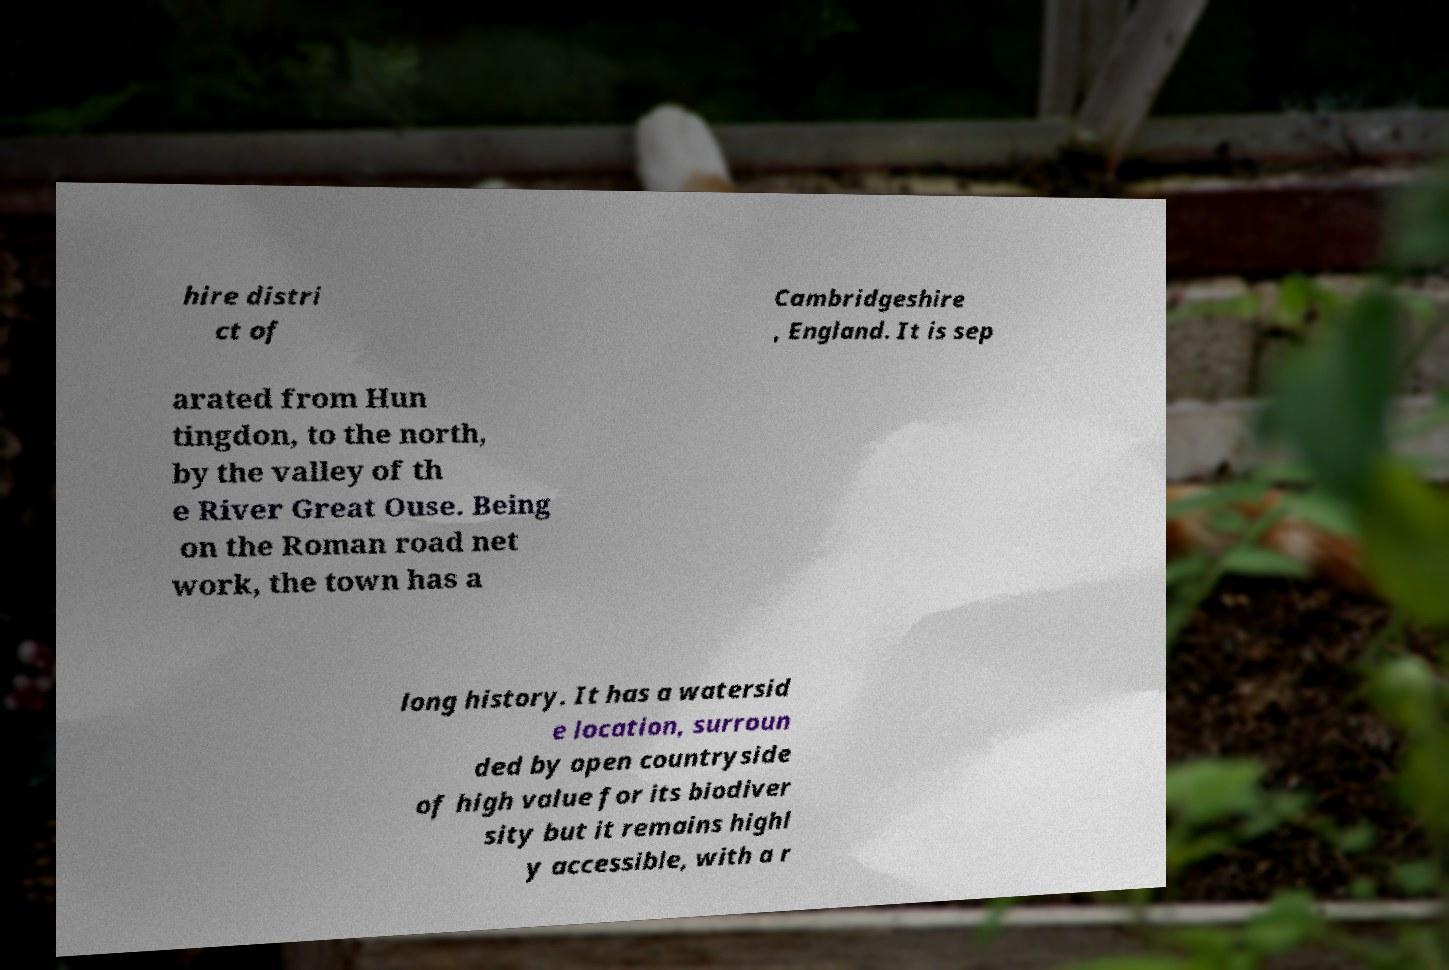For documentation purposes, I need the text within this image transcribed. Could you provide that? hire distri ct of Cambridgeshire , England. It is sep arated from Hun tingdon, to the north, by the valley of th e River Great Ouse. Being on the Roman road net work, the town has a long history. It has a watersid e location, surroun ded by open countryside of high value for its biodiver sity but it remains highl y accessible, with a r 